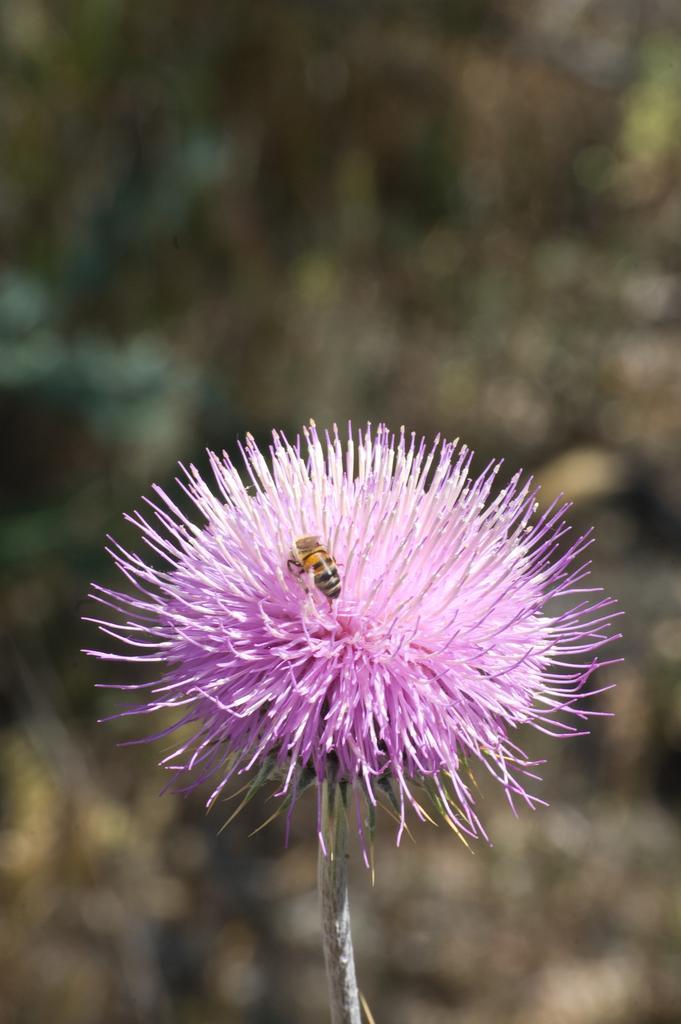Describe this image in one or two sentences. This is the picture of a flower. In this image there is a pink color flower and there is a honey bee on the flower. At the back the image is blurry. 